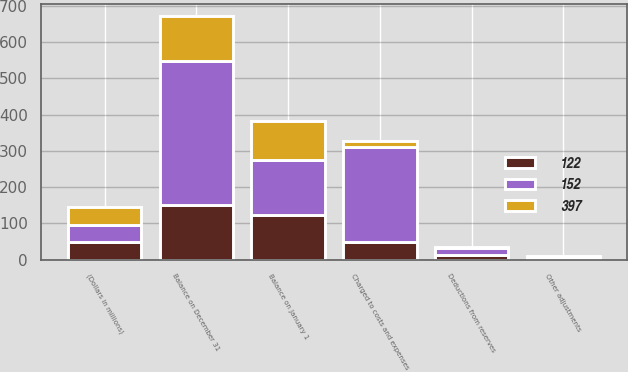Convert chart to OTSL. <chart><loc_0><loc_0><loc_500><loc_500><stacked_bar_chart><ecel><fcel>(Dollars in millions)<fcel>Balance on January 1<fcel>Charged to costs and expenses<fcel>Deductions from reserves<fcel>Other adjustments<fcel>Balance on December 31<nl><fcel>397<fcel>48<fcel>108<fcel>18<fcel>1<fcel>5<fcel>122<nl><fcel>122<fcel>48<fcel>122<fcel>48<fcel>14<fcel>4<fcel>152<nl><fcel>152<fcel>48<fcel>152<fcel>262<fcel>19<fcel>2<fcel>397<nl></chart> 